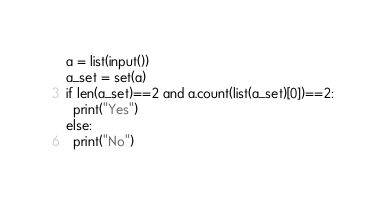Convert code to text. <code><loc_0><loc_0><loc_500><loc_500><_Python_>a = list(input())
a_set = set(a)
if len(a_set)==2 and a.count(list(a_set)[0])==2:
  print("Yes")
else:
  print("No")</code> 